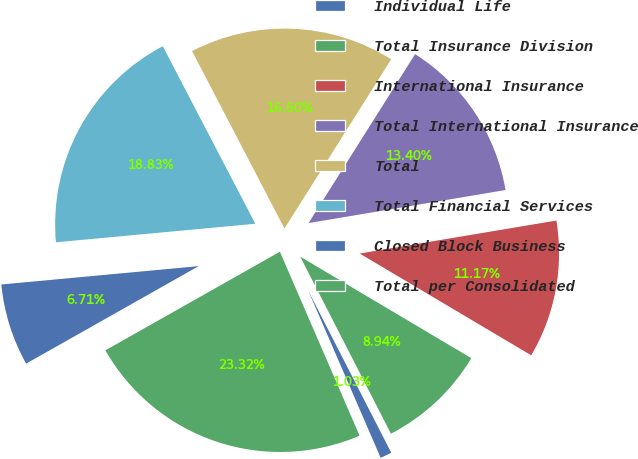Convert chart. <chart><loc_0><loc_0><loc_500><loc_500><pie_chart><fcel>Individual Life<fcel>Total Insurance Division<fcel>International Insurance<fcel>Total International Insurance<fcel>Total<fcel>Total Financial Services<fcel>Closed Block Business<fcel>Total per Consolidated<nl><fcel>1.03%<fcel>8.94%<fcel>11.17%<fcel>13.4%<fcel>16.6%<fcel>18.83%<fcel>6.71%<fcel>23.32%<nl></chart> 